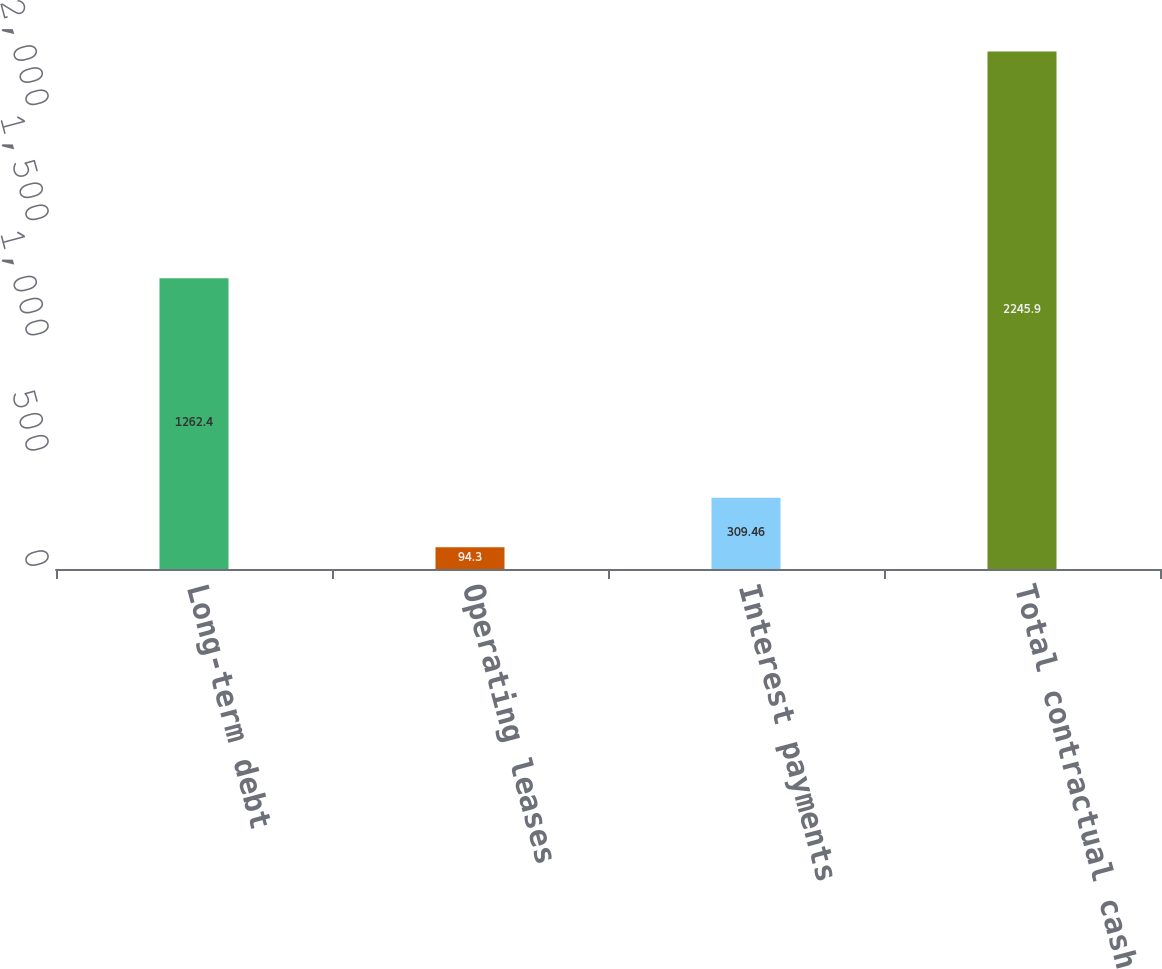Convert chart. <chart><loc_0><loc_0><loc_500><loc_500><bar_chart><fcel>Long-term debt<fcel>Operating leases<fcel>Interest payments<fcel>Total contractual cash<nl><fcel>1262.4<fcel>94.3<fcel>309.46<fcel>2245.9<nl></chart> 